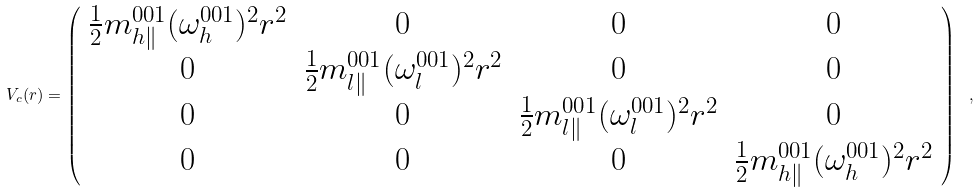Convert formula to latex. <formula><loc_0><loc_0><loc_500><loc_500>V _ { c } ( { r } ) = \left ( \begin{array} { c c c c } \frac { 1 } { 2 } m _ { h \| } ^ { 0 0 1 } ( \omega _ { h } ^ { 0 0 1 } ) ^ { 2 } r ^ { 2 } & 0 & 0 & 0 \\ 0 & \frac { 1 } { 2 } m _ { l \| } ^ { 0 0 1 } ( \omega _ { l } ^ { 0 0 1 } ) ^ { 2 } r ^ { 2 } & 0 & 0 \\ 0 & 0 & \frac { 1 } { 2 } m _ { l \| } ^ { 0 0 1 } ( \omega _ { l } ^ { 0 0 1 } ) ^ { 2 } r ^ { 2 } & 0 \\ 0 & 0 & 0 & \frac { 1 } { 2 } m _ { h \| } ^ { 0 0 1 } ( \omega _ { h } ^ { 0 0 1 } ) ^ { 2 } r ^ { 2 } \end{array} \right ) \ ,</formula> 